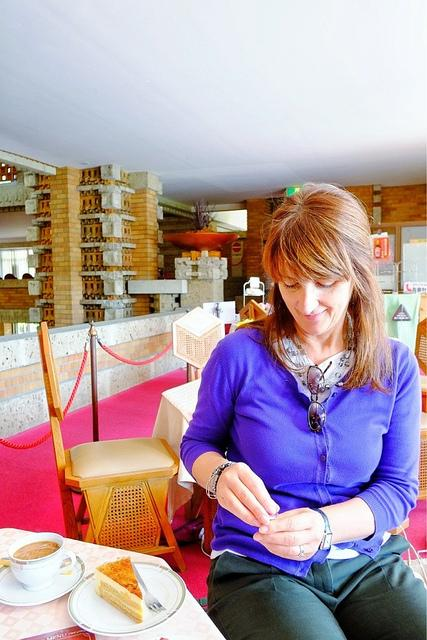Why is the woman sitting? Please explain your reasoning. to eat. There is food on a plate in front of the person on a table, and the backdrop is a restaurant. 